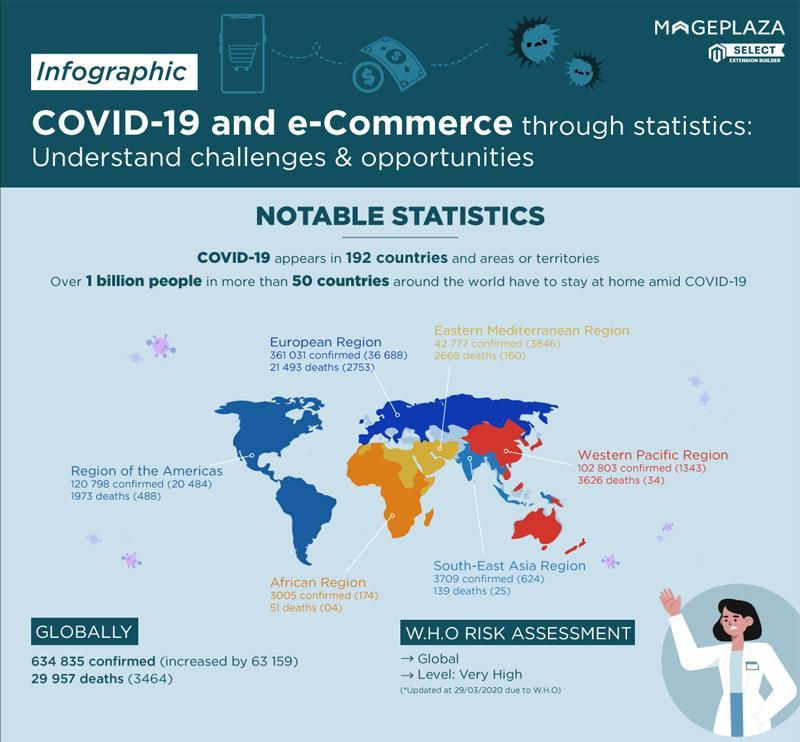What is the number of confirmed cases in the European region?
Answer the question with a short phrase. 361,031 Which region has the lowest number of deaths? African region By how much is a number of confirmed cases in South-East Asia higher than Africa? 704 What is the total number of confirmed cases in the world as on 29 March 2020? 634835 What is the number of deaths in Africa? 51 What is the number of deaths in the Western Pacific region? 3626 What is the number of global deaths? 29957 What is the 'increase' in the number of deaths in Africa? 04 What is the number of confirmed cases in the African region? 3005 What is the 'increase' in confirmed cases in the African region? 174 Which region has the highest number of deaths? European region Which region has the highest number of confirmed cases? European region What is the number of deaths in the region of Americas? 1973 